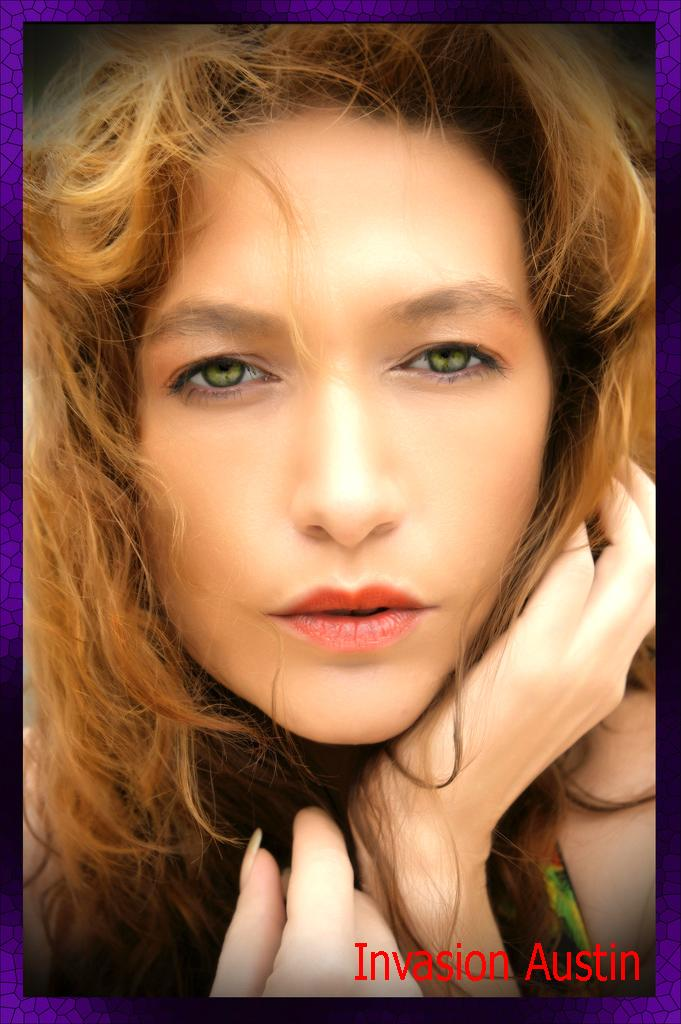Who is the main subject in the image? There is a woman in the center of the image. What else can be seen at the bottom of the image? There is text at the bottom of the image. What type of engine is being used by the woman in the image? There is no engine present in the image; it features a woman and text. What is the woman doing with the pot in the image? There is no pot present in the image; it only features a woman and text. 